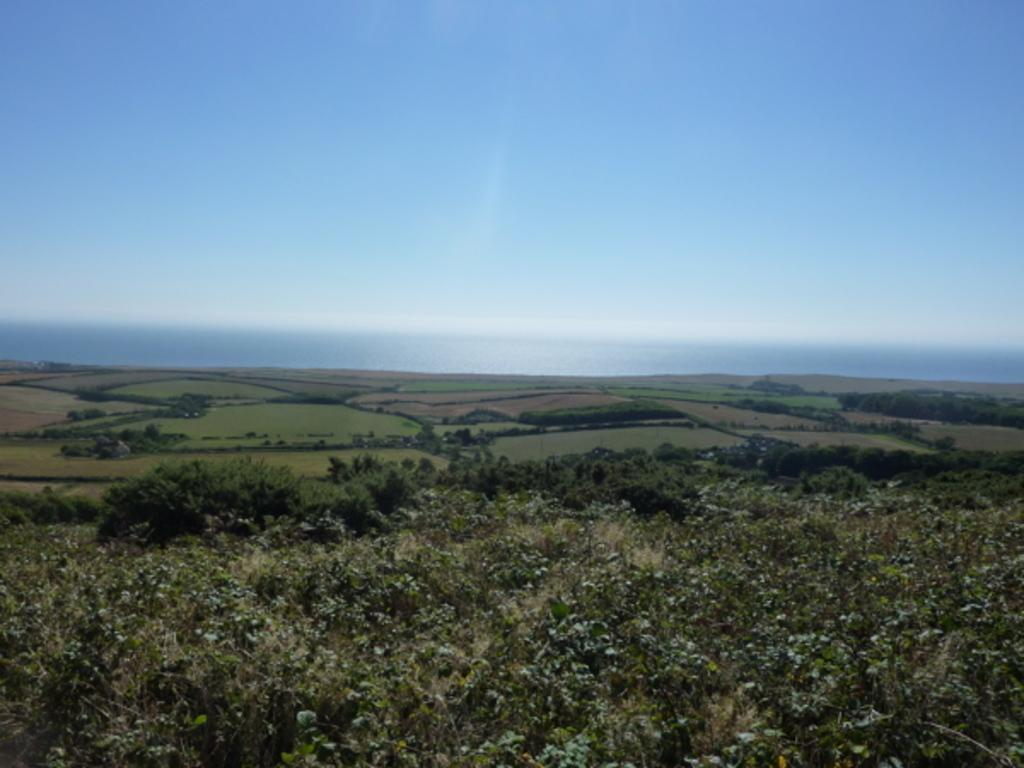What type of surface can be seen in the image? There is ground visible in the image. What type of vegetation is present in the image? There are plants and trees in the image. What part of the natural environment is visible in the background of the image? The sky is visible in the background of the image. What type of cub can be seen playing in the snow in the image? There is no cub or snow present in the image; it features ground, plants, trees, and the sky. 